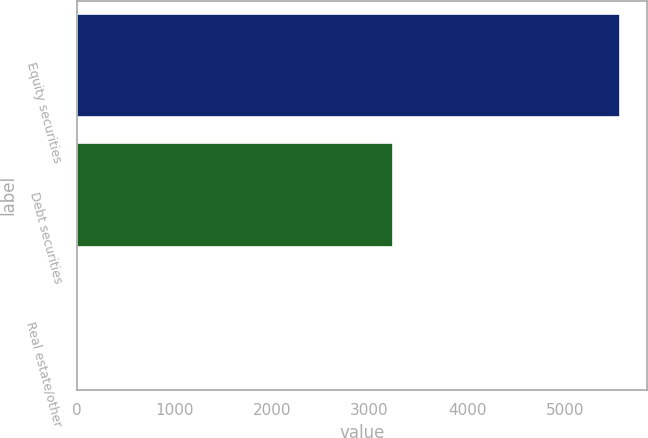<chart> <loc_0><loc_0><loc_500><loc_500><bar_chart><fcel>Equity securities<fcel>Debt securities<fcel>Real estate/other<nl><fcel>5567<fcel>3243<fcel>2<nl></chart> 